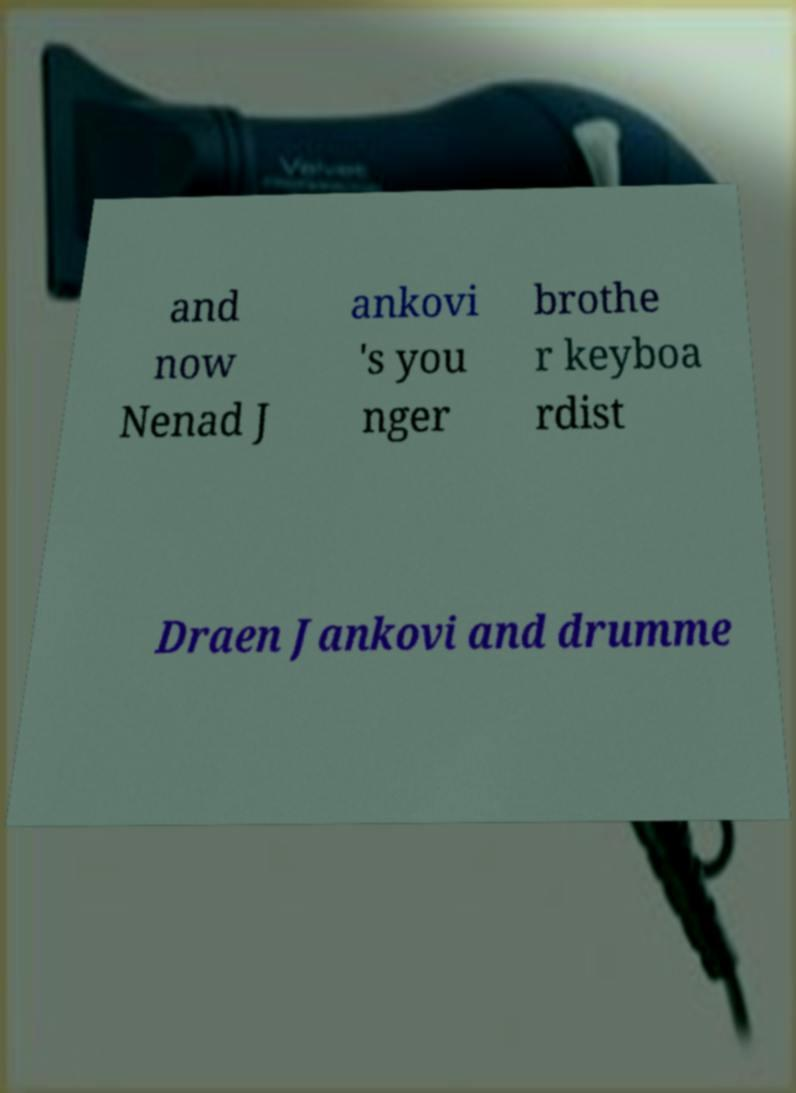Please identify and transcribe the text found in this image. and now Nenad J ankovi 's you nger brothe r keyboa rdist Draen Jankovi and drumme 